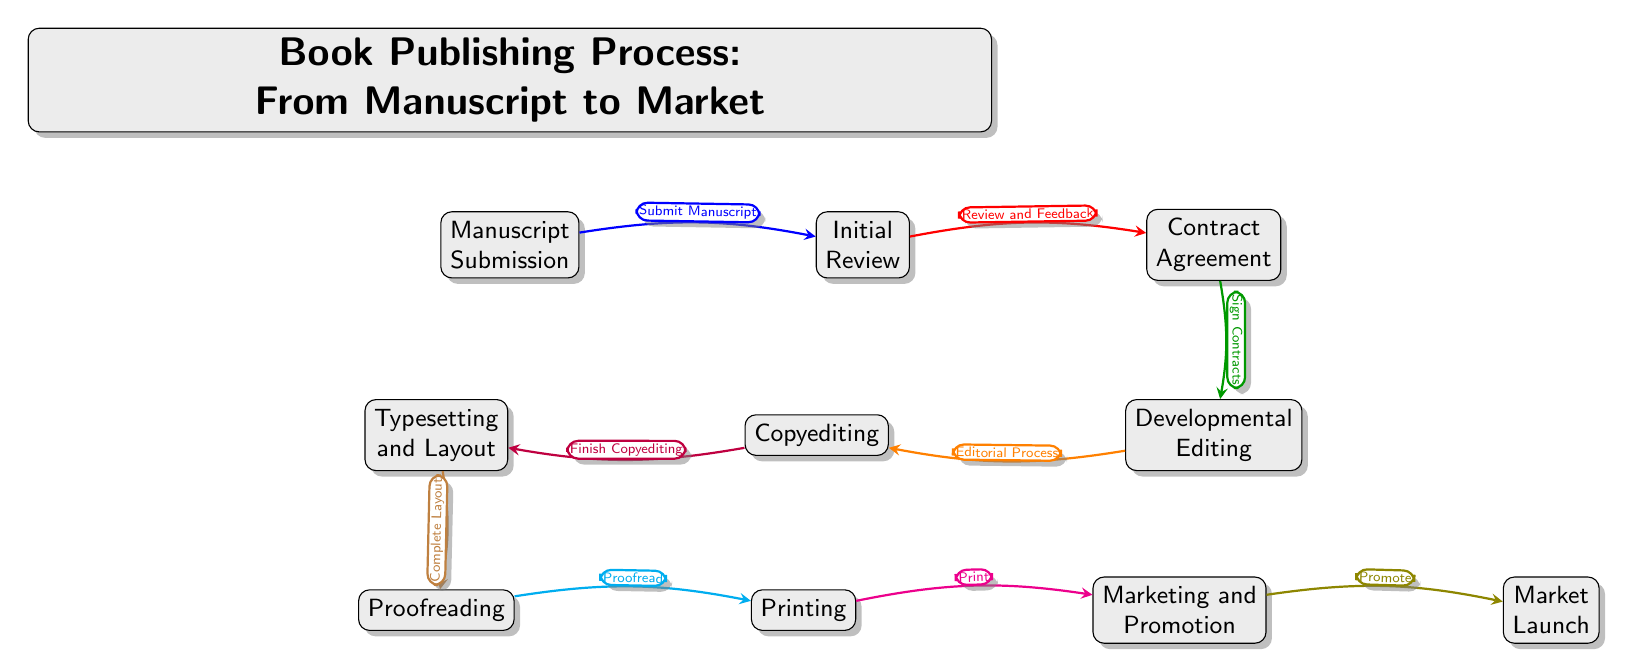What is the first milestone in the publishing process? The first milestone in the diagram is represented by the node labeled "Manuscript Submission." This is the starting point of the book publishing process.
Answer: Manuscript Submission How many total nodes are in the diagram? By counting each box (node) in the Gantt chart, there are a total of ten distinct milestones represented.
Answer: 10 What is the fourth step in the publishing process? The fourth step in the diagram, as indicated by the arrangement of nodes from left to right, is the "Developmental Editing" phase.
Answer: Developmental Editing Which milestone comes directly after "Proofreading"? Following the "Proofreading" stage in the sequence shown in the diagram, the next milestone is "Printing." This indicates a linear progression from one phase to another.
Answer: Printing What is the relationship between "Initial Review" and "Contract Agreement"? The "Initial Review" node is linked to the "Contract Agreement" node, indicating that after the review and feedback process, a contract is signed. This is a direct connection in the publishing workflow.
Answer: Review and Feedback What milestone is associated with the final stage of the publishing process? The final milestone shown in the diagram is "Market Launch," which signifies the book's entry into the market after all prior steps have been completed.
Answer: Market Launch How does "Marketing and Promotion" relate to "Printing"? The diagram illustrates that "Marketing and Promotion" follows the "Printing" stage, demonstrating that these activities occur after the book is physically printed, as part of the final preparations for market launch.
Answer: Promote In which order do "Copyediting" and "Typesetting and Layout" occur? The diagram shows that "Copyediting" is completed before "Typesetting and Layout," which indicates that the editing must come first to prepare the text for layout.
Answer: Copyediting, Typesetting and Layout 